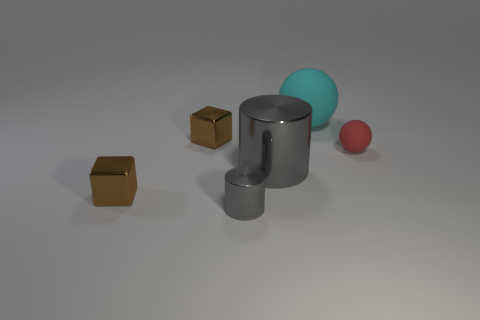Add 1 tiny purple cylinders. How many objects exist? 7 Subtract all cylinders. How many objects are left? 4 Subtract all tiny gray metal things. Subtract all large blue cylinders. How many objects are left? 5 Add 6 shiny objects. How many shiny objects are left? 10 Add 1 cylinders. How many cylinders exist? 3 Subtract 0 yellow blocks. How many objects are left? 6 